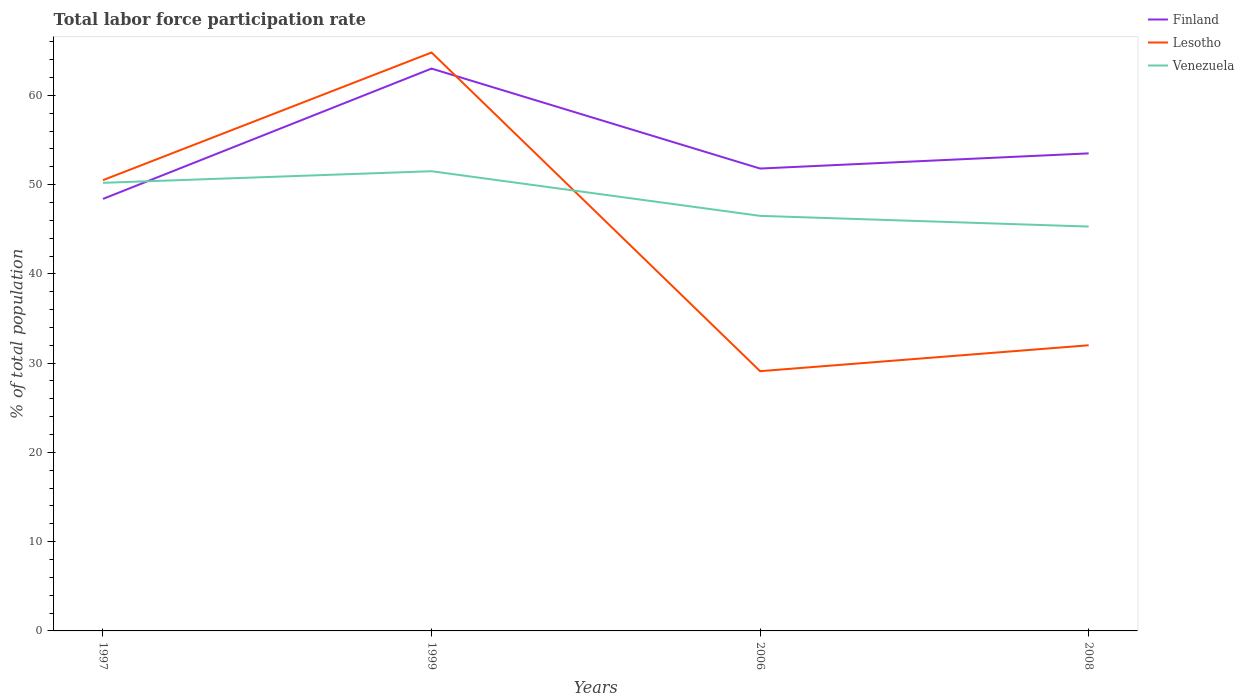How many different coloured lines are there?
Offer a terse response. 3. Across all years, what is the maximum total labor force participation rate in Venezuela?
Offer a very short reply. 45.3. In which year was the total labor force participation rate in Finland maximum?
Your answer should be compact. 1997. What is the total total labor force participation rate in Venezuela in the graph?
Your answer should be very brief. 6.2. What is the difference between the highest and the second highest total labor force participation rate in Venezuela?
Provide a succinct answer. 6.2. What is the difference between the highest and the lowest total labor force participation rate in Lesotho?
Give a very brief answer. 2. Is the total labor force participation rate in Lesotho strictly greater than the total labor force participation rate in Venezuela over the years?
Give a very brief answer. No. How many years are there in the graph?
Keep it short and to the point. 4. Does the graph contain any zero values?
Ensure brevity in your answer.  No. Does the graph contain grids?
Your answer should be very brief. No. How many legend labels are there?
Keep it short and to the point. 3. How are the legend labels stacked?
Provide a succinct answer. Vertical. What is the title of the graph?
Provide a short and direct response. Total labor force participation rate. What is the label or title of the Y-axis?
Offer a very short reply. % of total population. What is the % of total population in Finland in 1997?
Offer a very short reply. 48.4. What is the % of total population in Lesotho in 1997?
Provide a short and direct response. 50.5. What is the % of total population of Venezuela in 1997?
Give a very brief answer. 50.2. What is the % of total population of Finland in 1999?
Offer a very short reply. 63. What is the % of total population in Lesotho in 1999?
Offer a very short reply. 64.8. What is the % of total population in Venezuela in 1999?
Give a very brief answer. 51.5. What is the % of total population of Finland in 2006?
Give a very brief answer. 51.8. What is the % of total population of Lesotho in 2006?
Your answer should be compact. 29.1. What is the % of total population of Venezuela in 2006?
Provide a succinct answer. 46.5. What is the % of total population in Finland in 2008?
Make the answer very short. 53.5. What is the % of total population in Lesotho in 2008?
Offer a terse response. 32. What is the % of total population in Venezuela in 2008?
Provide a short and direct response. 45.3. Across all years, what is the maximum % of total population in Finland?
Your answer should be compact. 63. Across all years, what is the maximum % of total population in Lesotho?
Offer a terse response. 64.8. Across all years, what is the maximum % of total population of Venezuela?
Your response must be concise. 51.5. Across all years, what is the minimum % of total population in Finland?
Your response must be concise. 48.4. Across all years, what is the minimum % of total population of Lesotho?
Provide a succinct answer. 29.1. Across all years, what is the minimum % of total population of Venezuela?
Give a very brief answer. 45.3. What is the total % of total population in Finland in the graph?
Offer a terse response. 216.7. What is the total % of total population of Lesotho in the graph?
Offer a very short reply. 176.4. What is the total % of total population in Venezuela in the graph?
Make the answer very short. 193.5. What is the difference between the % of total population of Finland in 1997 and that in 1999?
Give a very brief answer. -14.6. What is the difference between the % of total population of Lesotho in 1997 and that in 1999?
Offer a very short reply. -14.3. What is the difference between the % of total population in Lesotho in 1997 and that in 2006?
Offer a very short reply. 21.4. What is the difference between the % of total population in Venezuela in 1997 and that in 2006?
Offer a terse response. 3.7. What is the difference between the % of total population of Finland in 1997 and that in 2008?
Provide a short and direct response. -5.1. What is the difference between the % of total population of Lesotho in 1997 and that in 2008?
Make the answer very short. 18.5. What is the difference between the % of total population of Lesotho in 1999 and that in 2006?
Provide a succinct answer. 35.7. What is the difference between the % of total population of Finland in 1999 and that in 2008?
Offer a very short reply. 9.5. What is the difference between the % of total population of Lesotho in 1999 and that in 2008?
Provide a short and direct response. 32.8. What is the difference between the % of total population in Venezuela in 1999 and that in 2008?
Your answer should be compact. 6.2. What is the difference between the % of total population of Venezuela in 2006 and that in 2008?
Your answer should be compact. 1.2. What is the difference between the % of total population of Finland in 1997 and the % of total population of Lesotho in 1999?
Keep it short and to the point. -16.4. What is the difference between the % of total population of Lesotho in 1997 and the % of total population of Venezuela in 1999?
Your answer should be very brief. -1. What is the difference between the % of total population in Finland in 1997 and the % of total population in Lesotho in 2006?
Your answer should be very brief. 19.3. What is the difference between the % of total population of Finland in 1997 and the % of total population of Venezuela in 2006?
Your answer should be compact. 1.9. What is the difference between the % of total population of Finland in 1997 and the % of total population of Venezuela in 2008?
Your answer should be very brief. 3.1. What is the difference between the % of total population of Finland in 1999 and the % of total population of Lesotho in 2006?
Provide a succinct answer. 33.9. What is the difference between the % of total population of Finland in 1999 and the % of total population of Venezuela in 2006?
Offer a very short reply. 16.5. What is the difference between the % of total population in Lesotho in 1999 and the % of total population in Venezuela in 2006?
Provide a succinct answer. 18.3. What is the difference between the % of total population of Finland in 1999 and the % of total population of Lesotho in 2008?
Offer a terse response. 31. What is the difference between the % of total population of Lesotho in 1999 and the % of total population of Venezuela in 2008?
Give a very brief answer. 19.5. What is the difference between the % of total population of Finland in 2006 and the % of total population of Lesotho in 2008?
Give a very brief answer. 19.8. What is the difference between the % of total population of Lesotho in 2006 and the % of total population of Venezuela in 2008?
Provide a succinct answer. -16.2. What is the average % of total population of Finland per year?
Provide a short and direct response. 54.17. What is the average % of total population of Lesotho per year?
Offer a terse response. 44.1. What is the average % of total population in Venezuela per year?
Your answer should be compact. 48.38. In the year 1997, what is the difference between the % of total population of Finland and % of total population of Lesotho?
Your response must be concise. -2.1. In the year 1997, what is the difference between the % of total population in Finland and % of total population in Venezuela?
Provide a succinct answer. -1.8. In the year 1999, what is the difference between the % of total population of Lesotho and % of total population of Venezuela?
Offer a terse response. 13.3. In the year 2006, what is the difference between the % of total population of Finland and % of total population of Lesotho?
Offer a terse response. 22.7. In the year 2006, what is the difference between the % of total population in Finland and % of total population in Venezuela?
Make the answer very short. 5.3. In the year 2006, what is the difference between the % of total population in Lesotho and % of total population in Venezuela?
Offer a very short reply. -17.4. In the year 2008, what is the difference between the % of total population of Lesotho and % of total population of Venezuela?
Ensure brevity in your answer.  -13.3. What is the ratio of the % of total population of Finland in 1997 to that in 1999?
Provide a short and direct response. 0.77. What is the ratio of the % of total population in Lesotho in 1997 to that in 1999?
Your answer should be compact. 0.78. What is the ratio of the % of total population in Venezuela in 1997 to that in 1999?
Your answer should be very brief. 0.97. What is the ratio of the % of total population of Finland in 1997 to that in 2006?
Offer a very short reply. 0.93. What is the ratio of the % of total population in Lesotho in 1997 to that in 2006?
Offer a terse response. 1.74. What is the ratio of the % of total population of Venezuela in 1997 to that in 2006?
Your answer should be compact. 1.08. What is the ratio of the % of total population of Finland in 1997 to that in 2008?
Keep it short and to the point. 0.9. What is the ratio of the % of total population in Lesotho in 1997 to that in 2008?
Offer a very short reply. 1.58. What is the ratio of the % of total population in Venezuela in 1997 to that in 2008?
Your answer should be very brief. 1.11. What is the ratio of the % of total population of Finland in 1999 to that in 2006?
Your answer should be compact. 1.22. What is the ratio of the % of total population of Lesotho in 1999 to that in 2006?
Keep it short and to the point. 2.23. What is the ratio of the % of total population of Venezuela in 1999 to that in 2006?
Ensure brevity in your answer.  1.11. What is the ratio of the % of total population of Finland in 1999 to that in 2008?
Provide a succinct answer. 1.18. What is the ratio of the % of total population in Lesotho in 1999 to that in 2008?
Your response must be concise. 2.02. What is the ratio of the % of total population in Venezuela in 1999 to that in 2008?
Your answer should be compact. 1.14. What is the ratio of the % of total population in Finland in 2006 to that in 2008?
Offer a very short reply. 0.97. What is the ratio of the % of total population of Lesotho in 2006 to that in 2008?
Give a very brief answer. 0.91. What is the ratio of the % of total population in Venezuela in 2006 to that in 2008?
Offer a terse response. 1.03. What is the difference between the highest and the second highest % of total population of Lesotho?
Your answer should be very brief. 14.3. What is the difference between the highest and the lowest % of total population in Lesotho?
Your response must be concise. 35.7. What is the difference between the highest and the lowest % of total population in Venezuela?
Give a very brief answer. 6.2. 